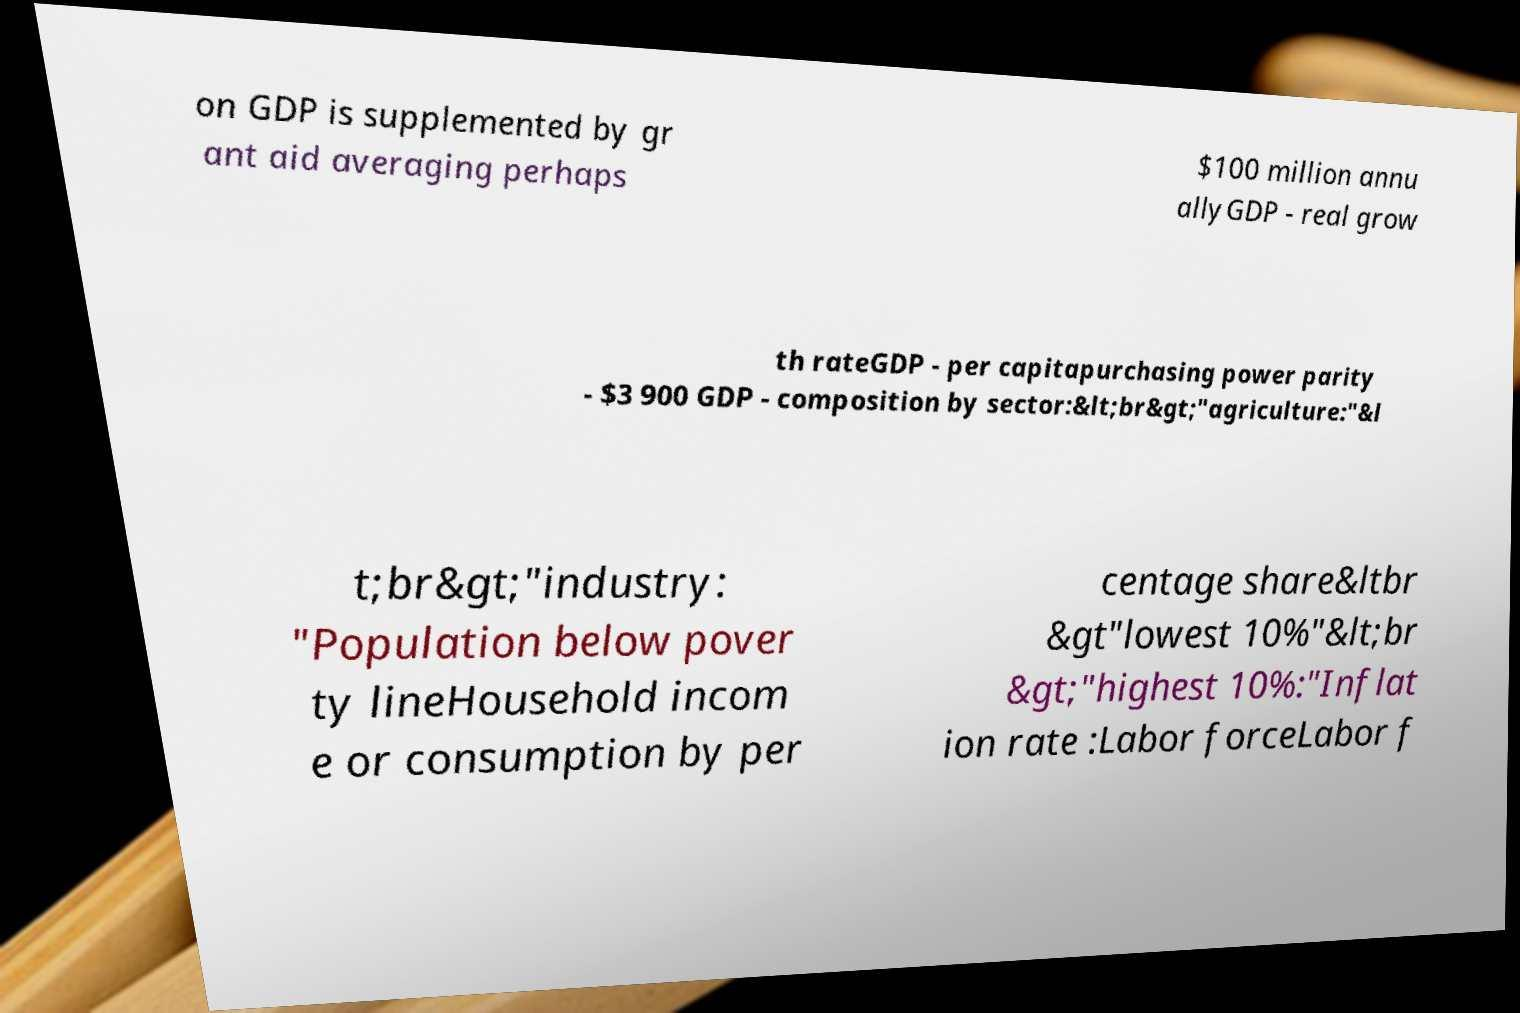Could you assist in decoding the text presented in this image and type it out clearly? on GDP is supplemented by gr ant aid averaging perhaps $100 million annu allyGDP - real grow th rateGDP - per capitapurchasing power parity - $3 900 GDP - composition by sector:&lt;br&gt;"agriculture:"&l t;br&gt;"industry: "Population below pover ty lineHousehold incom e or consumption by per centage share&ltbr &gt"lowest 10%"&lt;br &gt;"highest 10%:"Inflat ion rate :Labor forceLabor f 